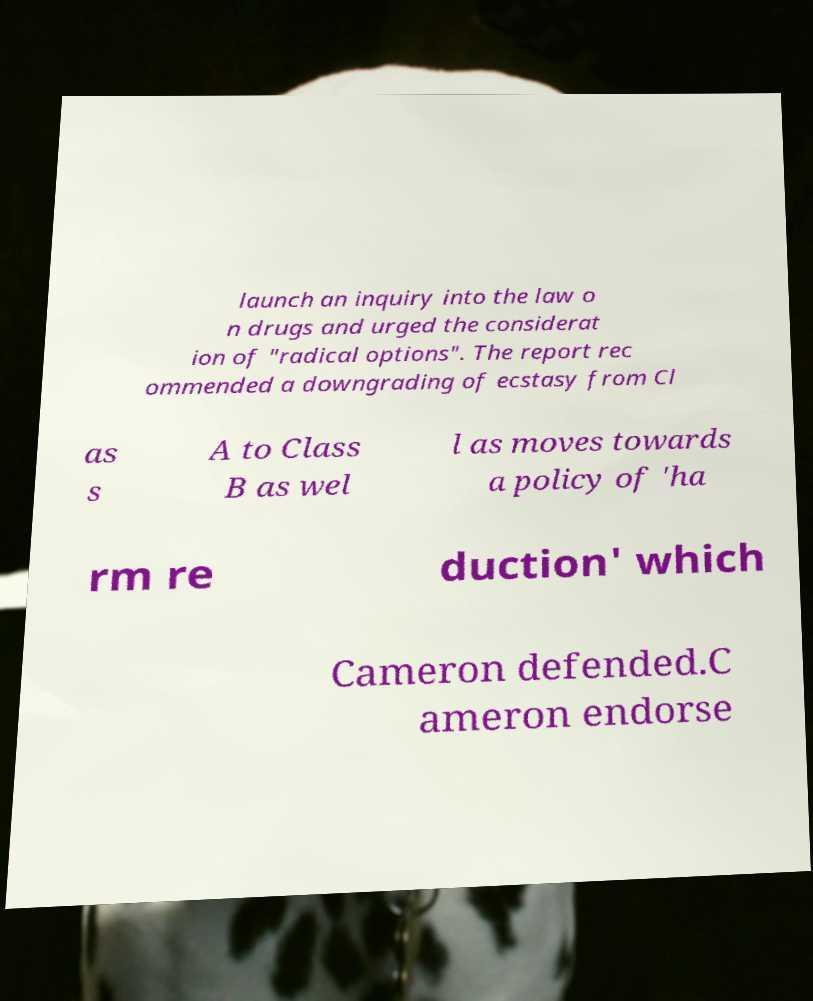For documentation purposes, I need the text within this image transcribed. Could you provide that? launch an inquiry into the law o n drugs and urged the considerat ion of "radical options". The report rec ommended a downgrading of ecstasy from Cl as s A to Class B as wel l as moves towards a policy of 'ha rm re duction' which Cameron defended.C ameron endorse 